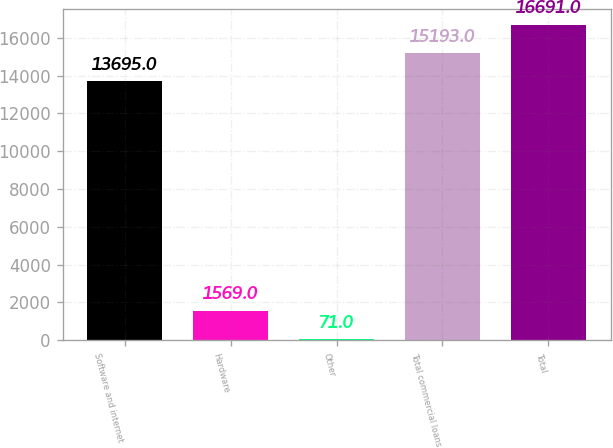Convert chart to OTSL. <chart><loc_0><loc_0><loc_500><loc_500><bar_chart><fcel>Software and internet<fcel>Hardware<fcel>Other<fcel>Total commercial loans<fcel>Total<nl><fcel>13695<fcel>1569<fcel>71<fcel>15193<fcel>16691<nl></chart> 